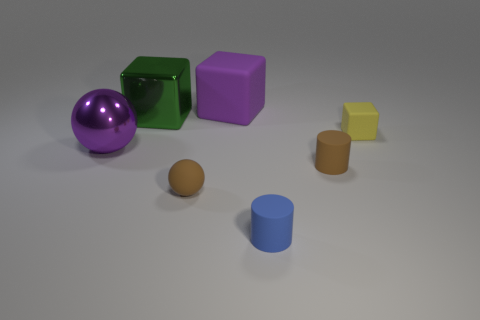Add 1 brown rubber objects. How many objects exist? 8 Subtract all blocks. How many objects are left? 4 Add 3 large purple matte objects. How many large purple matte objects are left? 4 Add 3 small yellow rubber spheres. How many small yellow rubber spheres exist? 3 Subtract 0 purple cylinders. How many objects are left? 7 Subtract all tiny blue cylinders. Subtract all large purple shiny things. How many objects are left? 5 